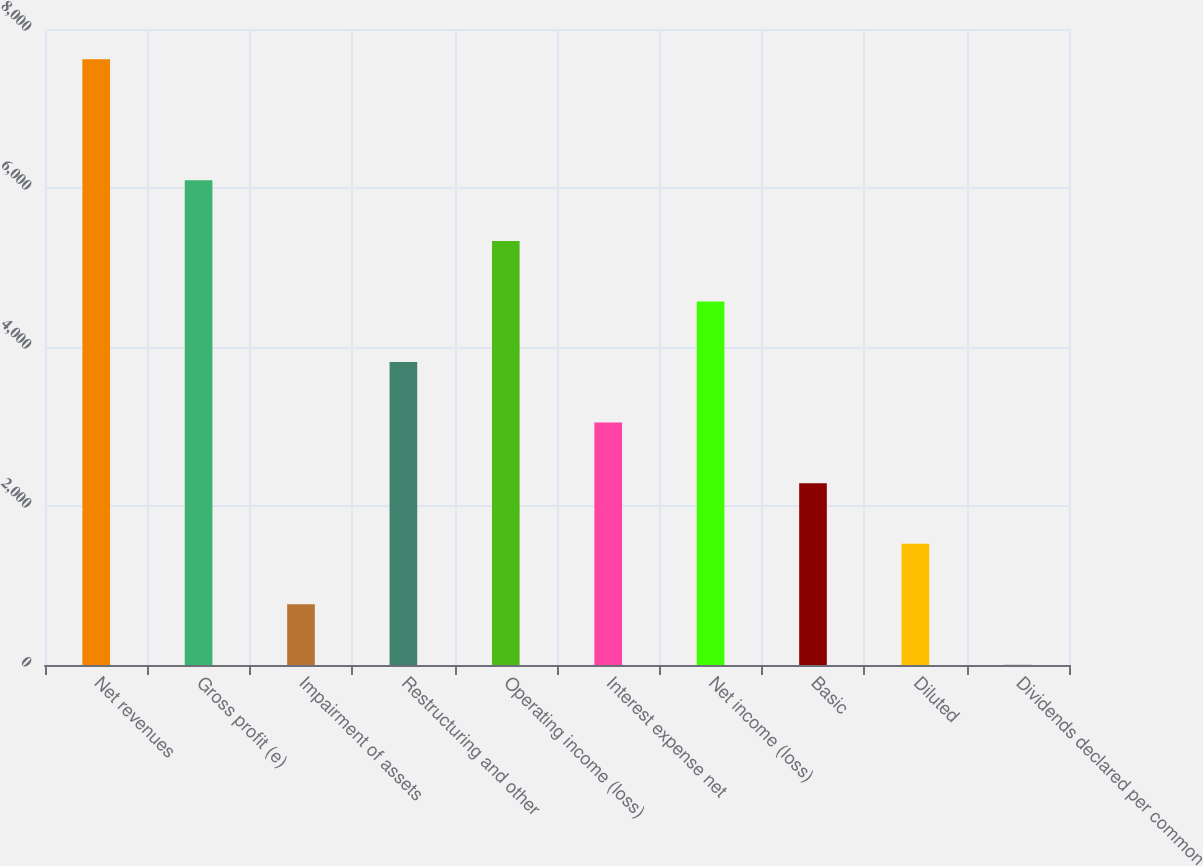Convert chart to OTSL. <chart><loc_0><loc_0><loc_500><loc_500><bar_chart><fcel>Net revenues<fcel>Gross profit (e)<fcel>Impairment of assets<fcel>Restructuring and other<fcel>Operating income (loss)<fcel>Interest expense net<fcel>Net income (loss)<fcel>Basic<fcel>Diluted<fcel>Dividends declared per common<nl><fcel>7620.3<fcel>6096.61<fcel>763.7<fcel>3811.07<fcel>5334.76<fcel>3049.23<fcel>4572.91<fcel>2287.39<fcel>1525.55<fcel>1.85<nl></chart> 